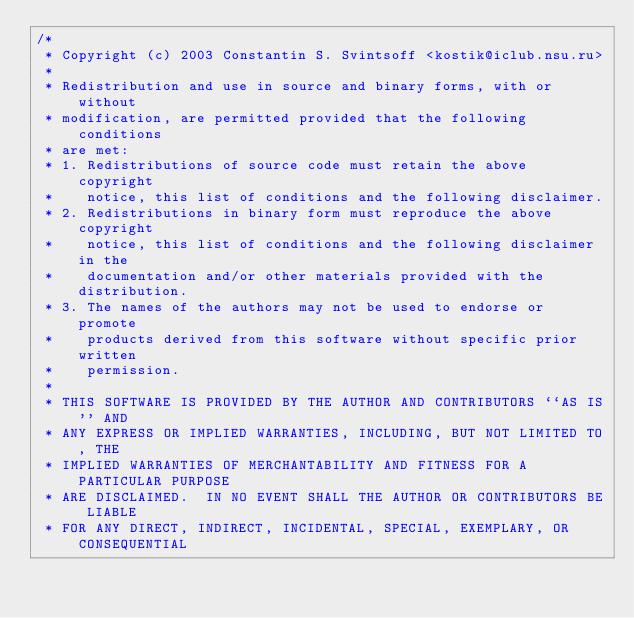<code> <loc_0><loc_0><loc_500><loc_500><_C_>/*
 * Copyright (c) 2003 Constantin S. Svintsoff <kostik@iclub.nsu.ru>
 *
 * Redistribution and use in source and binary forms, with or without
 * modification, are permitted provided that the following conditions
 * are met:
 * 1. Redistributions of source code must retain the above copyright
 *    notice, this list of conditions and the following disclaimer.
 * 2. Redistributions in binary form must reproduce the above copyright
 *    notice, this list of conditions and the following disclaimer in the
 *    documentation and/or other materials provided with the distribution.
 * 3. The names of the authors may not be used to endorse or promote
 *    products derived from this software without specific prior written
 *    permission.
 *
 * THIS SOFTWARE IS PROVIDED BY THE AUTHOR AND CONTRIBUTORS ``AS IS'' AND
 * ANY EXPRESS OR IMPLIED WARRANTIES, INCLUDING, BUT NOT LIMITED TO, THE
 * IMPLIED WARRANTIES OF MERCHANTABILITY AND FITNESS FOR A PARTICULAR PURPOSE
 * ARE DISCLAIMED.  IN NO EVENT SHALL THE AUTHOR OR CONTRIBUTORS BE LIABLE
 * FOR ANY DIRECT, INDIRECT, INCIDENTAL, SPECIAL, EXEMPLARY, OR CONSEQUENTIAL</code> 